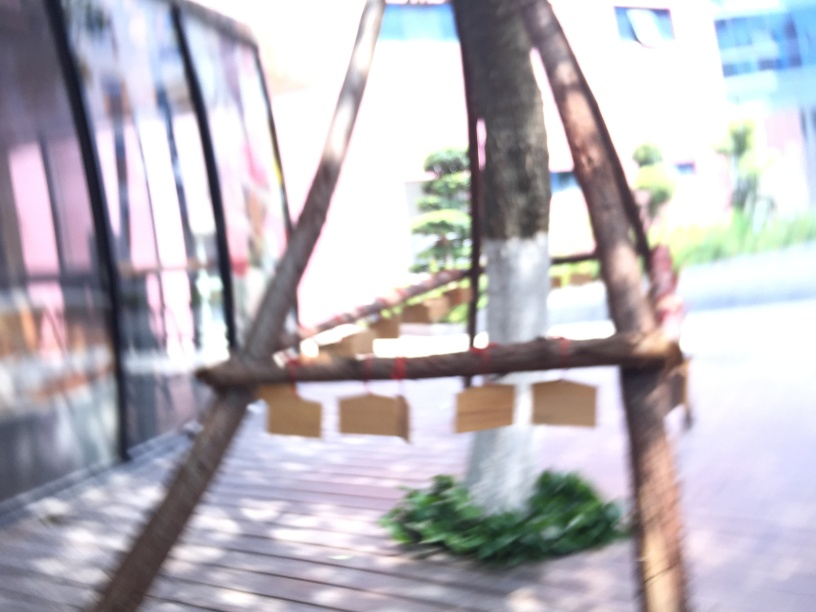What might have caused the image to be blurry? Was this an artistic choice or an error? The blurriness of the image could be due to several factors, such as motion blur from a moving subject or camera shake, incorrect focus settings, or a shallow depth of field. It's not possible to determine whether this was an intentional artistic choice or an error without further context, but often, such a level of blurriness is not desired in conventional photography. 